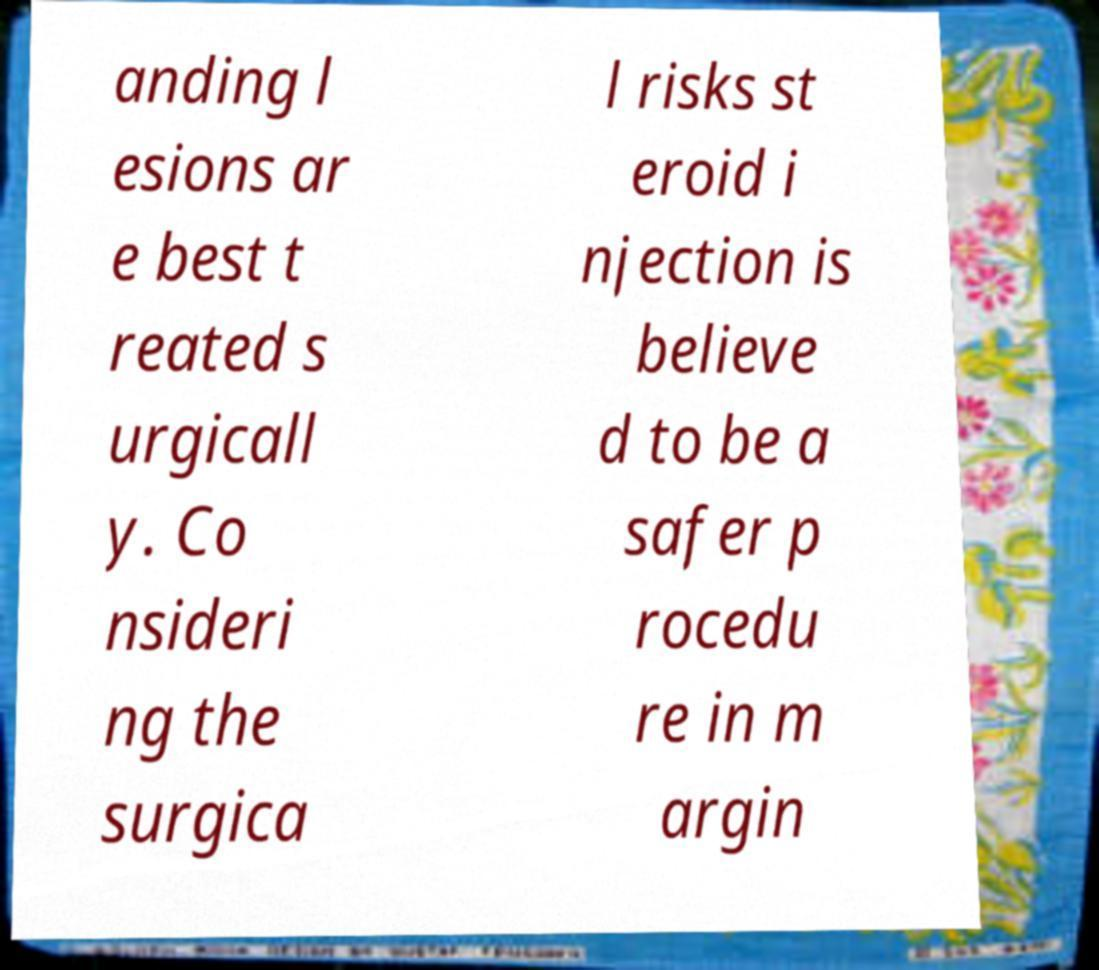What messages or text are displayed in this image? I need them in a readable, typed format. anding l esions ar e best t reated s urgicall y. Co nsideri ng the surgica l risks st eroid i njection is believe d to be a safer p rocedu re in m argin 